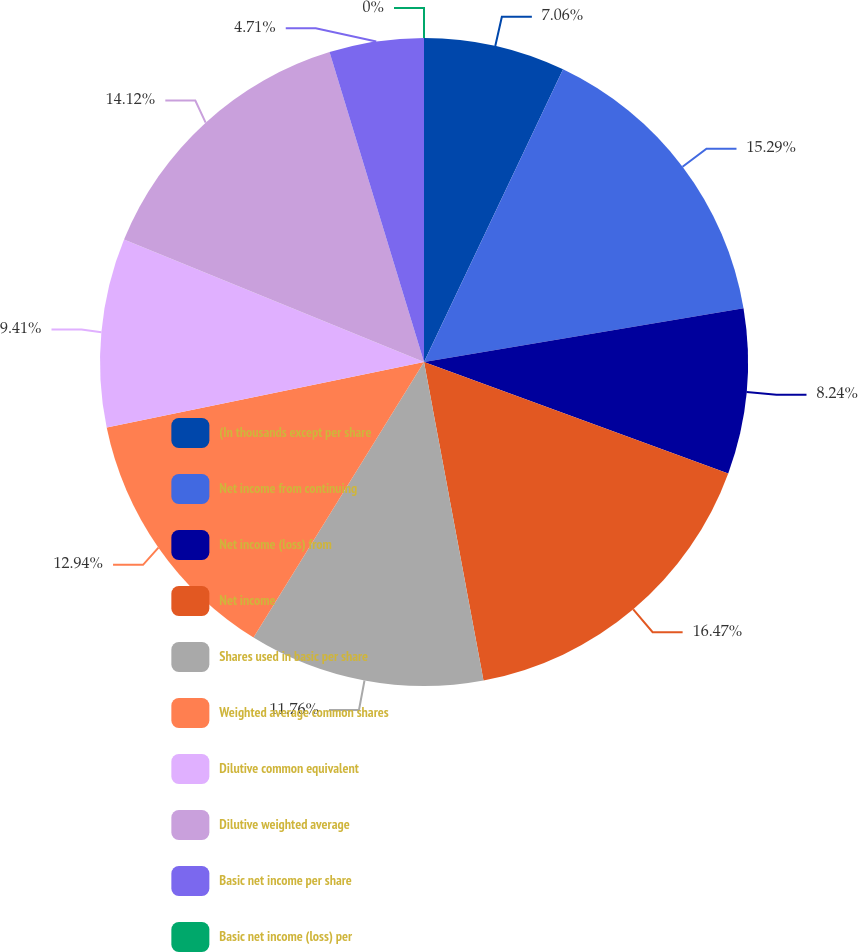Convert chart. <chart><loc_0><loc_0><loc_500><loc_500><pie_chart><fcel>(In thousands except per share<fcel>Net income from continuing<fcel>Net income (loss) from<fcel>Net income<fcel>Shares used in basic per share<fcel>Weighted average common shares<fcel>Dilutive common equivalent<fcel>Dilutive weighted average<fcel>Basic net income per share<fcel>Basic net income (loss) per<nl><fcel>7.06%<fcel>15.29%<fcel>8.24%<fcel>16.47%<fcel>11.76%<fcel>12.94%<fcel>9.41%<fcel>14.12%<fcel>4.71%<fcel>0.0%<nl></chart> 